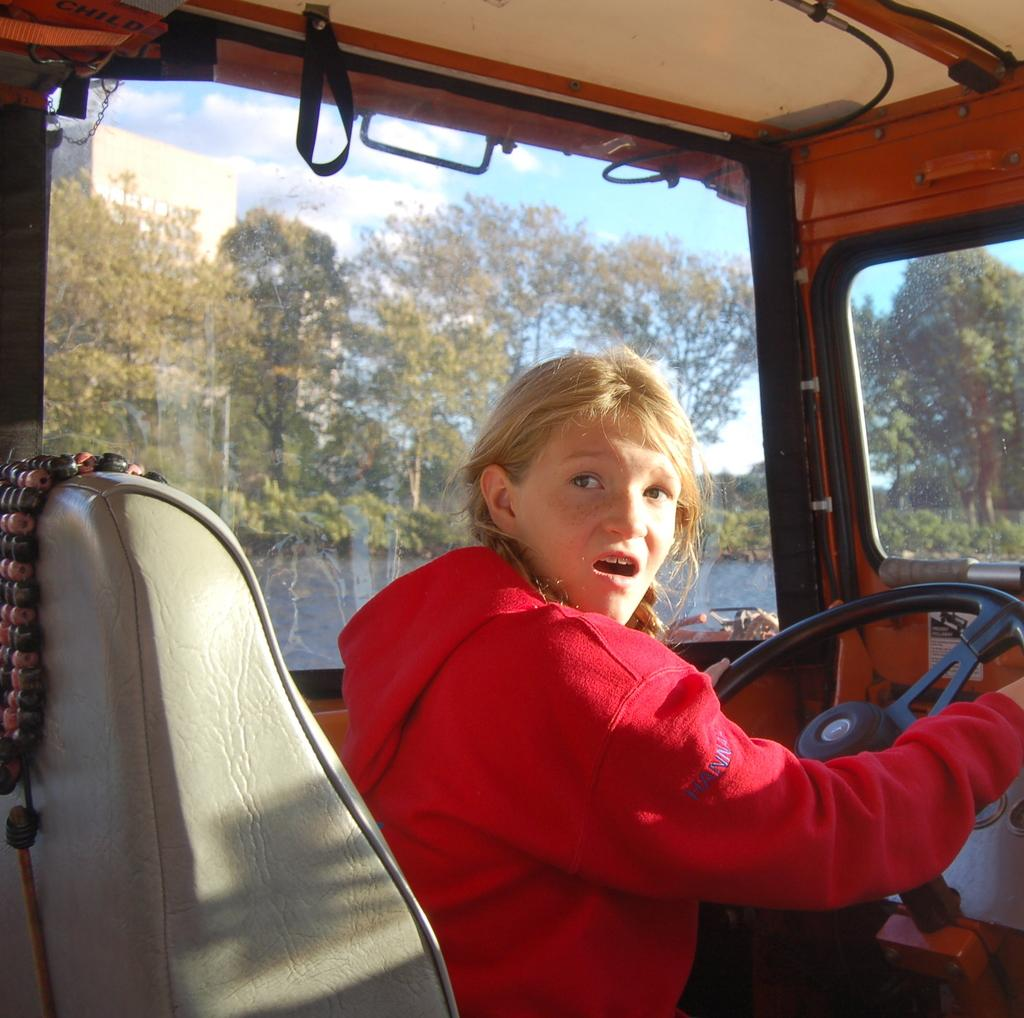Who is the main subject in the image? There is a girl in the image. What is the girl doing in the image? The girl is driving a truck. In which direction is the girl looking? The girl is looking to the right side. What type of window can be seen in the image? There is a glass window in the image. What type of vegetation is visible in the image? There are trees visible in the image. What is the condition of the sky in the image? The sky is clear in the image. What type of scene is depicted in the image? The image does not depict a scene; it is a photograph of a girl driving a truck. Can you tell me how many pears are visible in the image? There are no pears present in the image. 